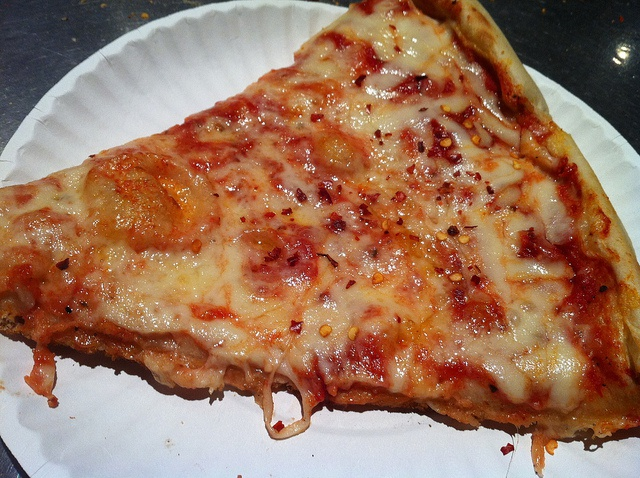Describe the objects in this image and their specific colors. I can see a pizza in black, brown, tan, and maroon tones in this image. 